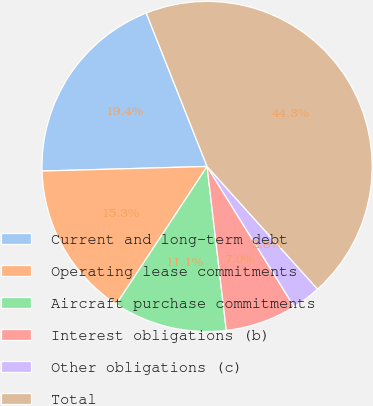Convert chart to OTSL. <chart><loc_0><loc_0><loc_500><loc_500><pie_chart><fcel>Current and long-term debt<fcel>Operating lease commitments<fcel>Aircraft purchase commitments<fcel>Interest obligations (b)<fcel>Other obligations (c)<fcel>Total<nl><fcel>19.43%<fcel>15.28%<fcel>11.13%<fcel>6.98%<fcel>2.83%<fcel>44.33%<nl></chart> 